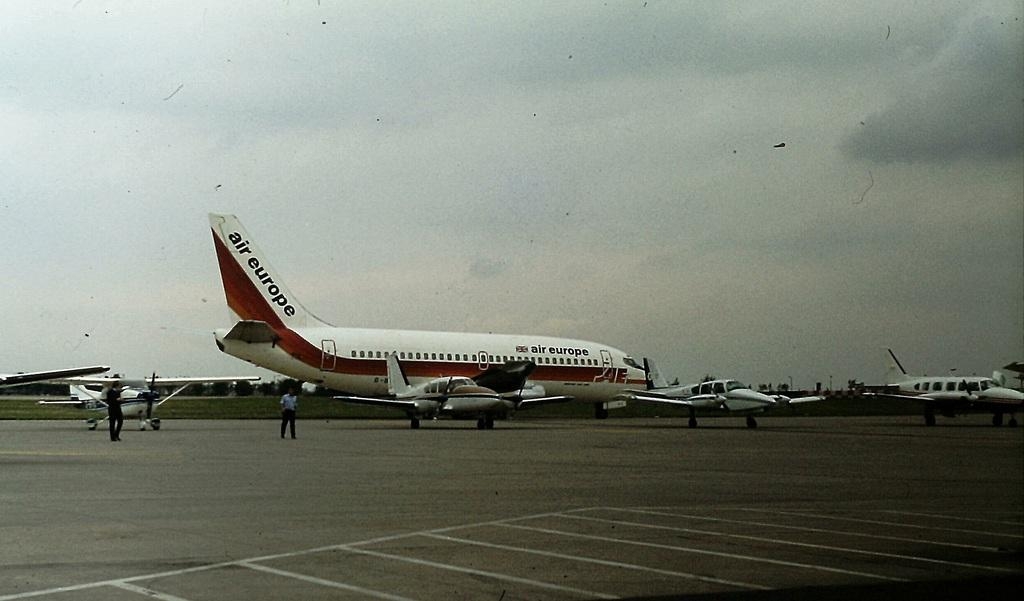<image>
Give a short and clear explanation of the subsequent image. A red and white Air Europe jet on the tarmac with other small white planes. 